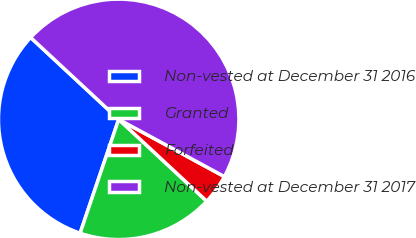Convert chart. <chart><loc_0><loc_0><loc_500><loc_500><pie_chart><fcel>Non-vested at December 31 2016<fcel>Granted<fcel>Forfeited<fcel>Non-vested at December 31 2017<nl><fcel>31.72%<fcel>18.28%<fcel>4.02%<fcel>45.98%<nl></chart> 